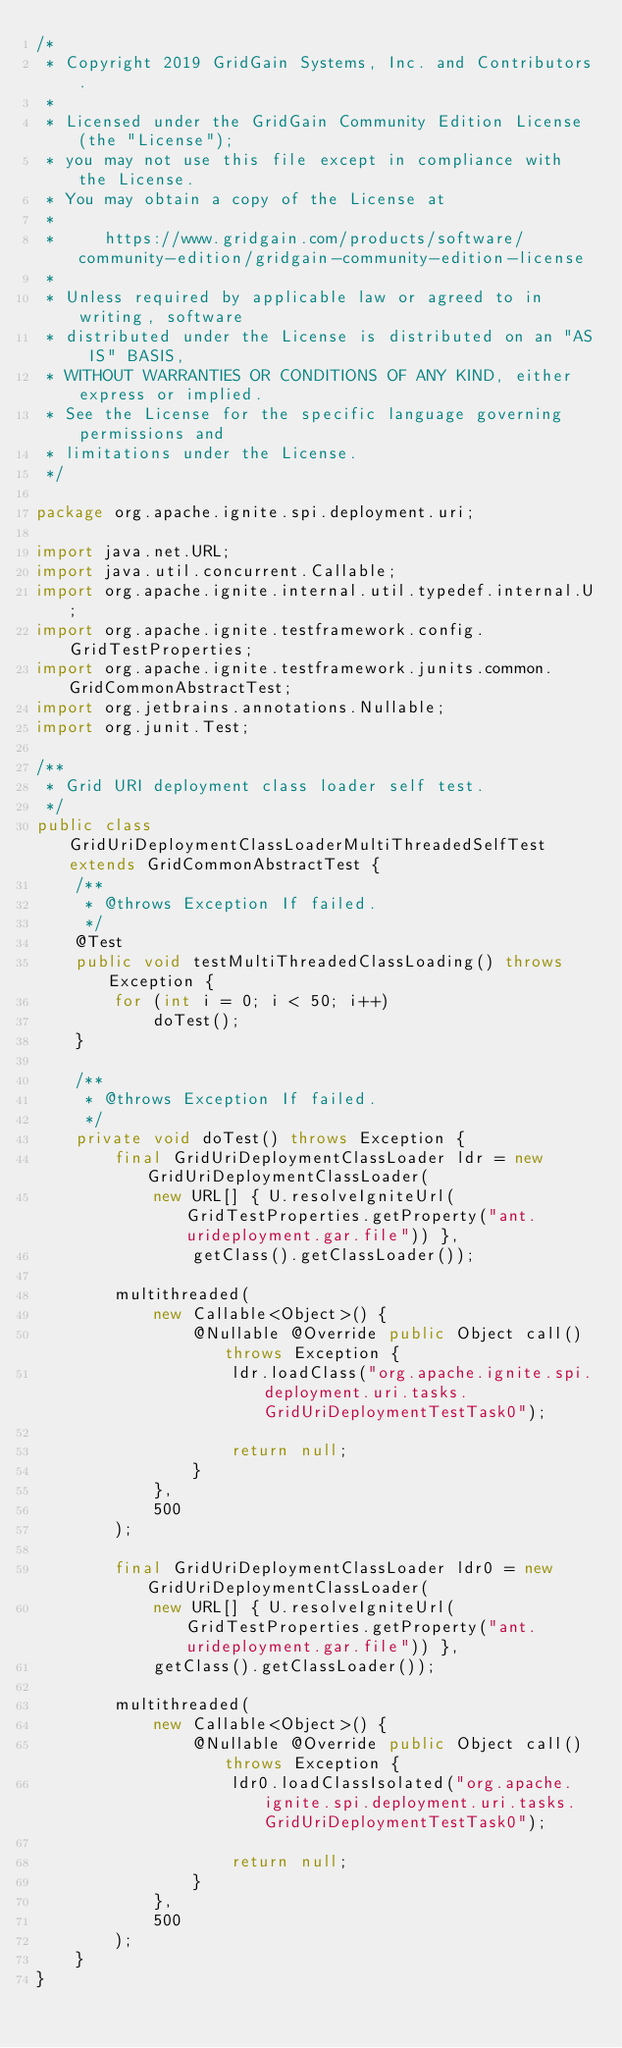Convert code to text. <code><loc_0><loc_0><loc_500><loc_500><_Java_>/*
 * Copyright 2019 GridGain Systems, Inc. and Contributors.
 *
 * Licensed under the GridGain Community Edition License (the "License");
 * you may not use this file except in compliance with the License.
 * You may obtain a copy of the License at
 *
 *     https://www.gridgain.com/products/software/community-edition/gridgain-community-edition-license
 *
 * Unless required by applicable law or agreed to in writing, software
 * distributed under the License is distributed on an "AS IS" BASIS,
 * WITHOUT WARRANTIES OR CONDITIONS OF ANY KIND, either express or implied.
 * See the License for the specific language governing permissions and
 * limitations under the License.
 */

package org.apache.ignite.spi.deployment.uri;

import java.net.URL;
import java.util.concurrent.Callable;
import org.apache.ignite.internal.util.typedef.internal.U;
import org.apache.ignite.testframework.config.GridTestProperties;
import org.apache.ignite.testframework.junits.common.GridCommonAbstractTest;
import org.jetbrains.annotations.Nullable;
import org.junit.Test;

/**
 * Grid URI deployment class loader self test.
 */
public class GridUriDeploymentClassLoaderMultiThreadedSelfTest extends GridCommonAbstractTest {
    /**
     * @throws Exception If failed.
     */
    @Test
    public void testMultiThreadedClassLoading() throws Exception {
        for (int i = 0; i < 50; i++)
            doTest();
    }

    /**
     * @throws Exception If failed.
     */
    private void doTest() throws Exception {
        final GridUriDeploymentClassLoader ldr = new GridUriDeploymentClassLoader(
            new URL[] { U.resolveIgniteUrl(GridTestProperties.getProperty("ant.urideployment.gar.file")) },
                getClass().getClassLoader());

        multithreaded(
            new Callable<Object>() {
                @Nullable @Override public Object call() throws Exception {
                    ldr.loadClass("org.apache.ignite.spi.deployment.uri.tasks.GridUriDeploymentTestTask0");

                    return null;
                }
            },
            500
        );

        final GridUriDeploymentClassLoader ldr0 = new GridUriDeploymentClassLoader(
            new URL[] { U.resolveIgniteUrl(GridTestProperties.getProperty("ant.urideployment.gar.file")) },
            getClass().getClassLoader());

        multithreaded(
            new Callable<Object>() {
                @Nullable @Override public Object call() throws Exception {
                    ldr0.loadClassIsolated("org.apache.ignite.spi.deployment.uri.tasks.GridUriDeploymentTestTask0");

                    return null;
                }
            },
            500
        );
    }
}
</code> 